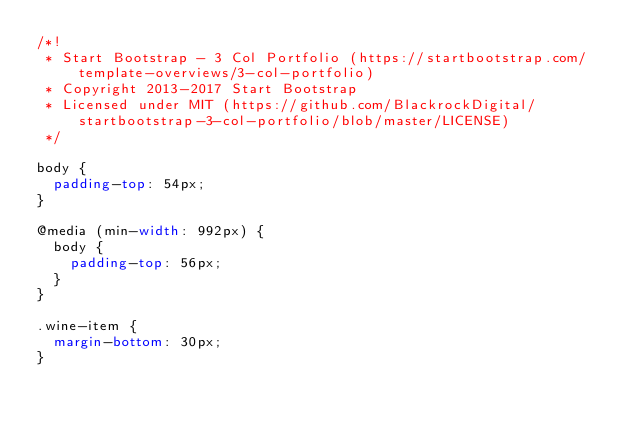Convert code to text. <code><loc_0><loc_0><loc_500><loc_500><_CSS_>/*!
 * Start Bootstrap - 3 Col Portfolio (https://startbootstrap.com/template-overviews/3-col-portfolio)
 * Copyright 2013-2017 Start Bootstrap
 * Licensed under MIT (https://github.com/BlackrockDigital/startbootstrap-3-col-portfolio/blob/master/LICENSE)
 */

body {
  padding-top: 54px;
}

@media (min-width: 992px) {
  body {
    padding-top: 56px;
  }
}

.wine-item {
  margin-bottom: 30px;
}
</code> 